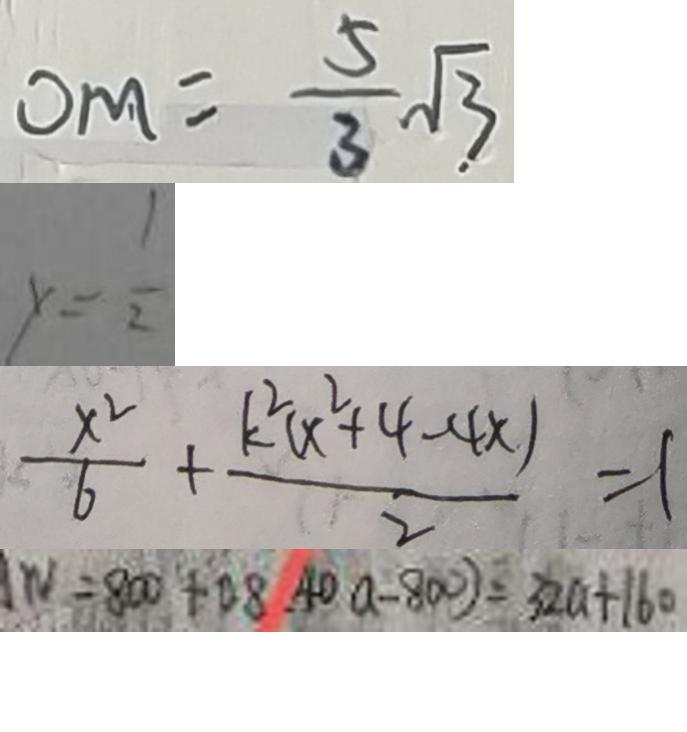Convert formula to latex. <formula><loc_0><loc_0><loc_500><loc_500>0 M = \frac { 5 } { 3 } \sqrt { 3 } 
 y = \frac { 1 } { 2 } 
 \frac { x ^ { 2 } } { 6 } + \frac { k ^ { 2 } ( x ^ { 2 } + 4 - 4 x ) } { 2 } = 1 
 W = 8 0 0 + 0 8 ( 4 0 a - 8 0 0 ) = 3 2 a + 1 6 0</formula> 